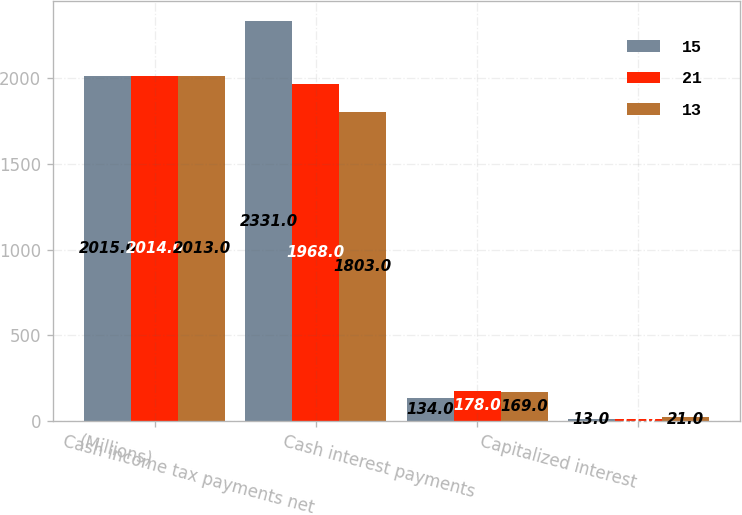Convert chart to OTSL. <chart><loc_0><loc_0><loc_500><loc_500><stacked_bar_chart><ecel><fcel>(Millions)<fcel>Cash income tax payments net<fcel>Cash interest payments<fcel>Capitalized interest<nl><fcel>15<fcel>2015<fcel>2331<fcel>134<fcel>13<nl><fcel>21<fcel>2014<fcel>1968<fcel>178<fcel>15<nl><fcel>13<fcel>2013<fcel>1803<fcel>169<fcel>21<nl></chart> 